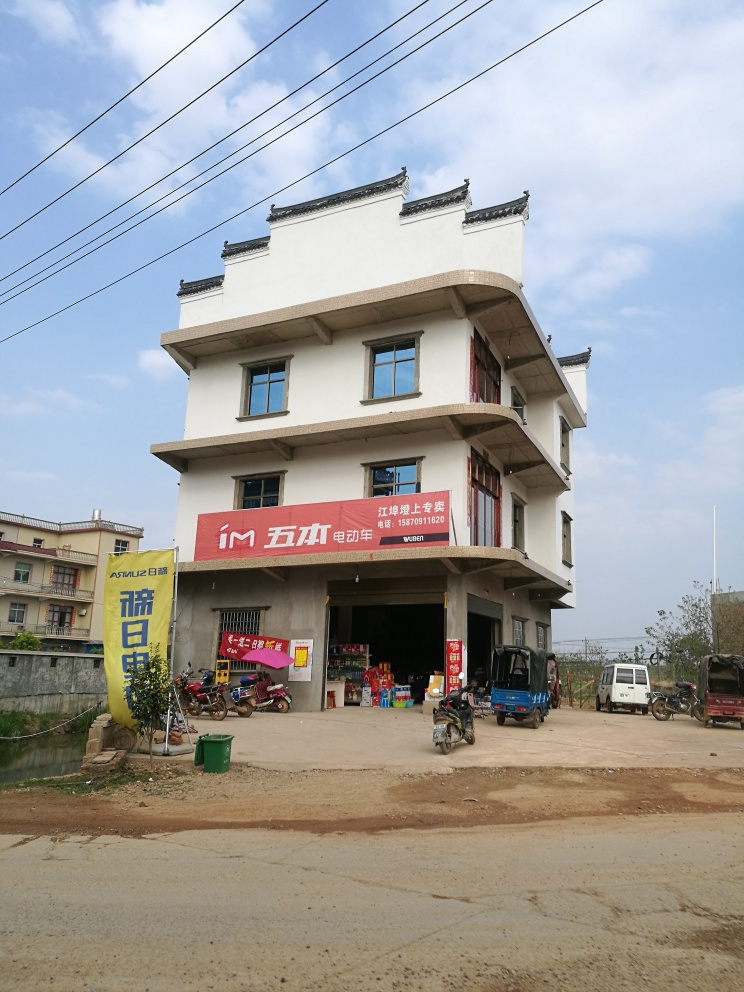Can you tell whether this photo was taken in an urban or rural setting? Based on the spacious setting around the building, the dirt road in the foreground, and the lack of densely packed structures typically seen in an urban environment, it is plausible that this photo was taken in a rural or semi-rural area. What time of the year or day could this photo likely have been taken? The photo features a clear blue sky with ample daylight, suggesting it could have been taken on a fair-weather day, likely in the late morning or early afternoon. The deciduous trees with green leaves hint that it might be during a warmer season like spring or summer. 